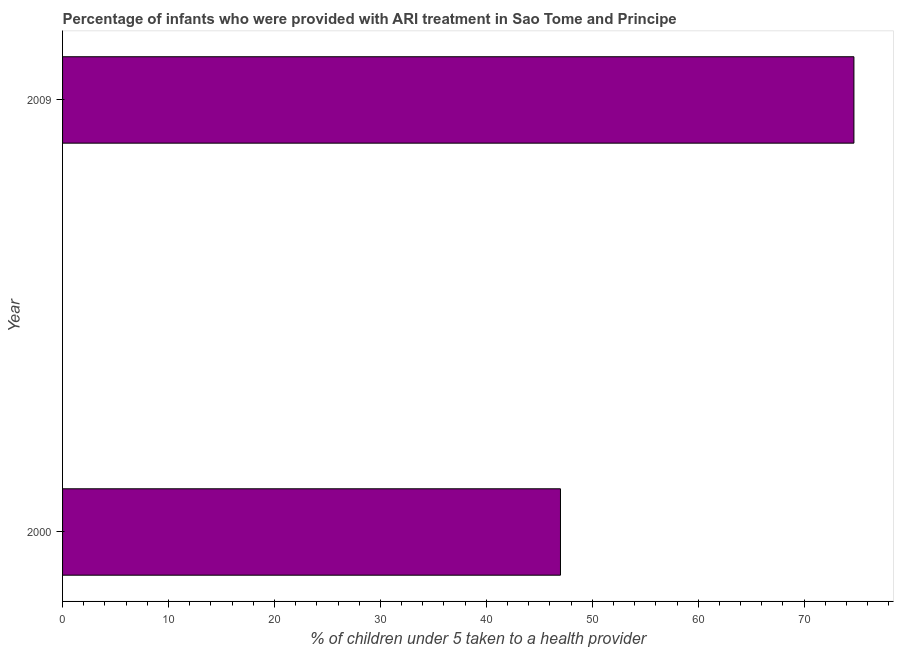Does the graph contain any zero values?
Ensure brevity in your answer.  No. What is the title of the graph?
Give a very brief answer. Percentage of infants who were provided with ARI treatment in Sao Tome and Principe. What is the label or title of the X-axis?
Make the answer very short. % of children under 5 taken to a health provider. What is the percentage of children who were provided with ari treatment in 2000?
Keep it short and to the point. 47. Across all years, what is the maximum percentage of children who were provided with ari treatment?
Your answer should be very brief. 74.7. In which year was the percentage of children who were provided with ari treatment maximum?
Make the answer very short. 2009. In which year was the percentage of children who were provided with ari treatment minimum?
Offer a very short reply. 2000. What is the sum of the percentage of children who were provided with ari treatment?
Your answer should be compact. 121.7. What is the difference between the percentage of children who were provided with ari treatment in 2000 and 2009?
Ensure brevity in your answer.  -27.7. What is the average percentage of children who were provided with ari treatment per year?
Offer a terse response. 60.85. What is the median percentage of children who were provided with ari treatment?
Your response must be concise. 60.85. In how many years, is the percentage of children who were provided with ari treatment greater than 6 %?
Give a very brief answer. 2. Do a majority of the years between 2000 and 2009 (inclusive) have percentage of children who were provided with ari treatment greater than 10 %?
Provide a short and direct response. Yes. What is the ratio of the percentage of children who were provided with ari treatment in 2000 to that in 2009?
Offer a very short reply. 0.63. In how many years, is the percentage of children who were provided with ari treatment greater than the average percentage of children who were provided with ari treatment taken over all years?
Keep it short and to the point. 1. How many bars are there?
Ensure brevity in your answer.  2. Are all the bars in the graph horizontal?
Make the answer very short. Yes. How many years are there in the graph?
Make the answer very short. 2. What is the % of children under 5 taken to a health provider in 2009?
Keep it short and to the point. 74.7. What is the difference between the % of children under 5 taken to a health provider in 2000 and 2009?
Your response must be concise. -27.7. What is the ratio of the % of children under 5 taken to a health provider in 2000 to that in 2009?
Provide a succinct answer. 0.63. 